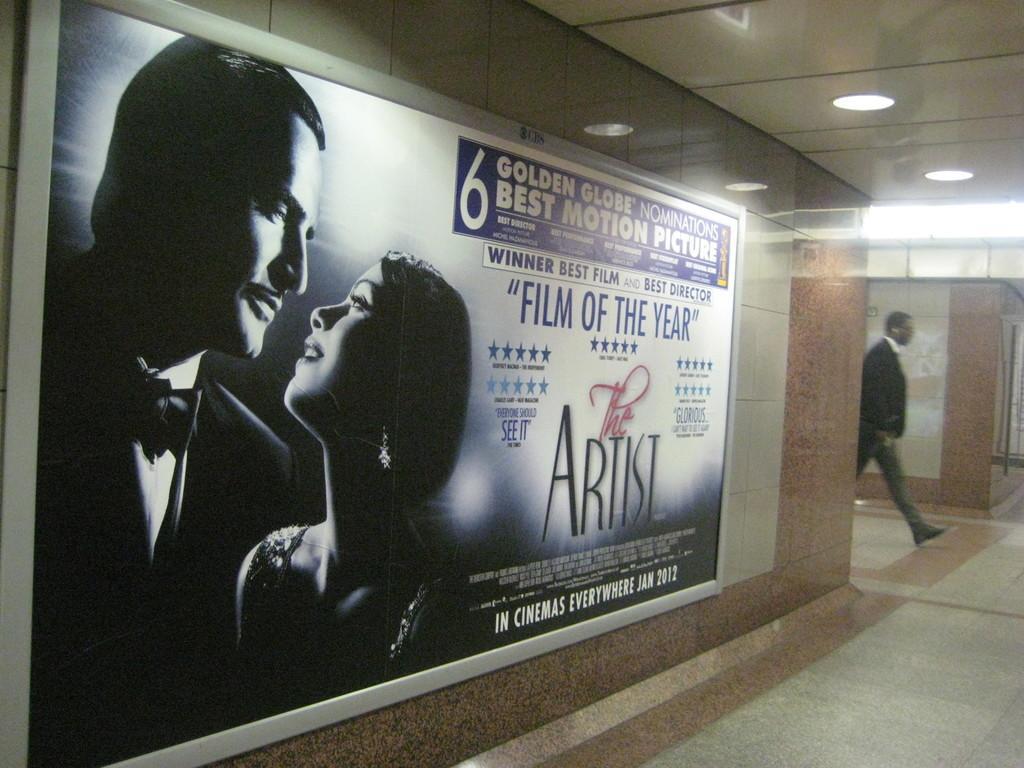How would you summarize this image in a sentence or two? In this picture, it looks like a poster of two people on the wall and on the poster it is written something. On the right side of the wall there is a person walking on the floor. At the top there are ceiling lights. 